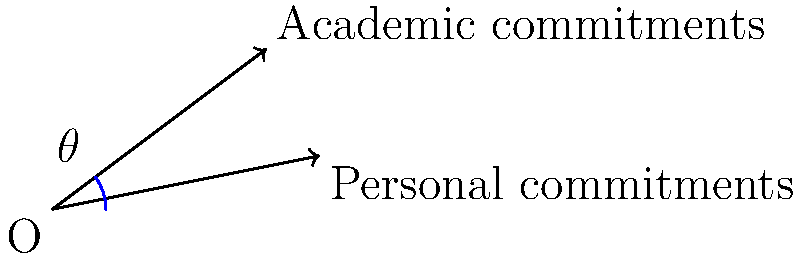In a graph representing the balance between academic and personal commitments, two lines are drawn from the origin. The line representing academic commitments has coordinates (4, 3), while the line for personal commitments has coordinates (5, 1). What is the angle $\theta$ between these two lines? To find the angle between two lines, we can use the dot product formula:

1) The dot product formula for the angle between two vectors is:
   $$\cos \theta = \frac{\vec{a} \cdot \vec{b}}{|\vec{a}||\vec{b}|}$$

2) Let $\vec{a} = (4, 3)$ and $\vec{b} = (5, 1)$

3) Calculate the dot product $\vec{a} \cdot \vec{b}$:
   $$\vec{a} \cdot \vec{b} = 4(5) + 3(1) = 20 + 3 = 23$$

4) Calculate the magnitudes:
   $$|\vec{a}| = \sqrt{4^2 + 3^2} = \sqrt{16 + 9} = \sqrt{25} = 5$$
   $$|\vec{b}| = \sqrt{5^2 + 1^2} = \sqrt{25 + 1} = \sqrt{26}$$

5) Substitute into the formula:
   $$\cos \theta = \frac{23}{5\sqrt{26}}$$

6) Take the inverse cosine (arccos) of both sides:
   $$\theta = \arccos(\frac{23}{5\sqrt{26}})$$

7) Calculate the result:
   $$\theta \approx 0.3398 \text{ radians} \approx 19.47°$$
Answer: $19.47°$ 